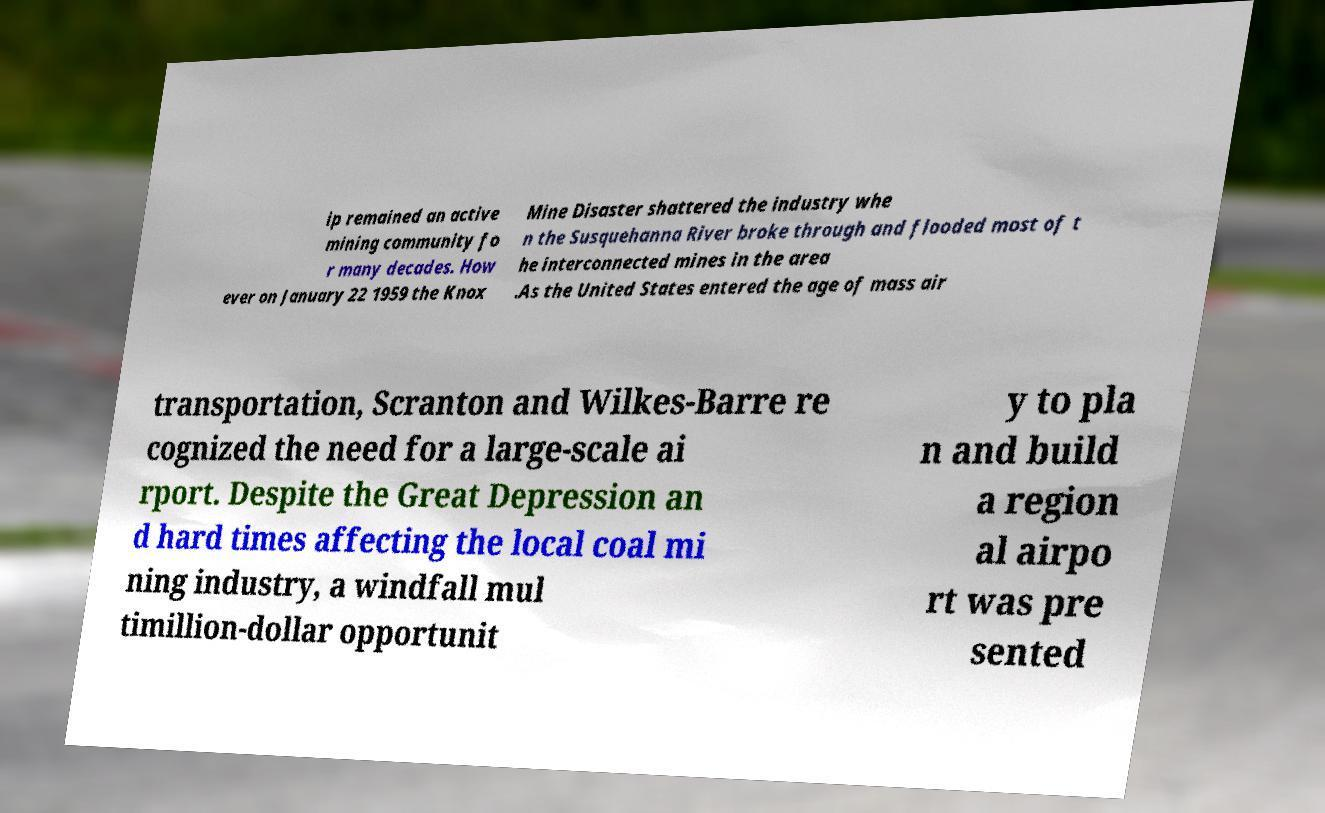Could you extract and type out the text from this image? ip remained an active mining community fo r many decades. How ever on January 22 1959 the Knox Mine Disaster shattered the industry whe n the Susquehanna River broke through and flooded most of t he interconnected mines in the area .As the United States entered the age of mass air transportation, Scranton and Wilkes-Barre re cognized the need for a large-scale ai rport. Despite the Great Depression an d hard times affecting the local coal mi ning industry, a windfall mul timillion-dollar opportunit y to pla n and build a region al airpo rt was pre sented 